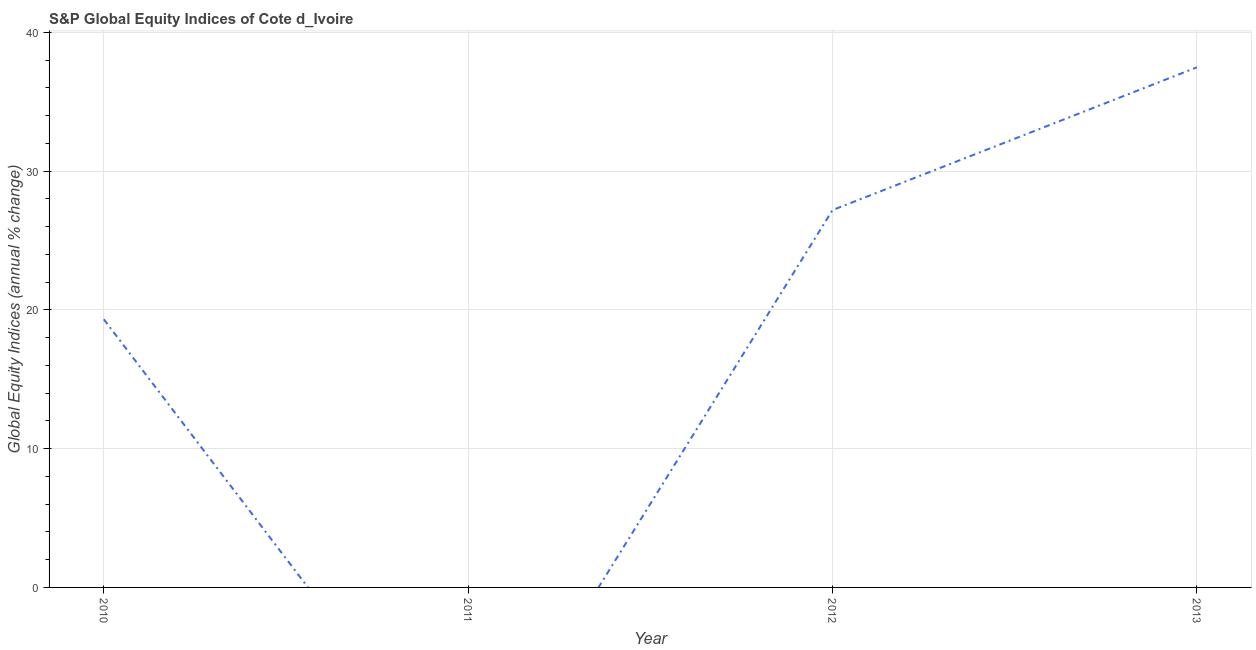What is the s&p global equity indices in 2012?
Your answer should be very brief. 27.19. Across all years, what is the maximum s&p global equity indices?
Give a very brief answer. 37.48. What is the sum of the s&p global equity indices?
Your answer should be compact. 84. What is the difference between the s&p global equity indices in 2010 and 2013?
Your response must be concise. -18.16. What is the average s&p global equity indices per year?
Your response must be concise. 21. What is the median s&p global equity indices?
Your answer should be very brief. 23.26. In how many years, is the s&p global equity indices greater than 26 %?
Your answer should be very brief. 2. What is the ratio of the s&p global equity indices in 2010 to that in 2013?
Give a very brief answer. 0.52. Is the s&p global equity indices in 2012 less than that in 2013?
Ensure brevity in your answer.  Yes. What is the difference between the highest and the second highest s&p global equity indices?
Offer a terse response. 10.29. What is the difference between the highest and the lowest s&p global equity indices?
Ensure brevity in your answer.  37.48. In how many years, is the s&p global equity indices greater than the average s&p global equity indices taken over all years?
Keep it short and to the point. 2. Does the s&p global equity indices monotonically increase over the years?
Provide a short and direct response. No. How many years are there in the graph?
Ensure brevity in your answer.  4. What is the difference between two consecutive major ticks on the Y-axis?
Provide a succinct answer. 10. Does the graph contain any zero values?
Your answer should be compact. Yes. What is the title of the graph?
Provide a short and direct response. S&P Global Equity Indices of Cote d_Ivoire. What is the label or title of the Y-axis?
Make the answer very short. Global Equity Indices (annual % change). What is the Global Equity Indices (annual % change) in 2010?
Provide a succinct answer. 19.32. What is the Global Equity Indices (annual % change) in 2012?
Make the answer very short. 27.19. What is the Global Equity Indices (annual % change) of 2013?
Keep it short and to the point. 37.48. What is the difference between the Global Equity Indices (annual % change) in 2010 and 2012?
Offer a terse response. -7.87. What is the difference between the Global Equity Indices (annual % change) in 2010 and 2013?
Make the answer very short. -18.16. What is the difference between the Global Equity Indices (annual % change) in 2012 and 2013?
Make the answer very short. -10.29. What is the ratio of the Global Equity Indices (annual % change) in 2010 to that in 2012?
Your response must be concise. 0.71. What is the ratio of the Global Equity Indices (annual % change) in 2010 to that in 2013?
Offer a terse response. 0.52. What is the ratio of the Global Equity Indices (annual % change) in 2012 to that in 2013?
Give a very brief answer. 0.73. 